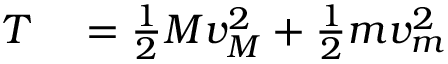<formula> <loc_0><loc_0><loc_500><loc_500>\begin{array} { r l } { T } & = { \frac { 1 } { 2 } } M v _ { M } ^ { 2 } + { \frac { 1 } { 2 } } m v _ { m } ^ { 2 } } \end{array}</formula> 